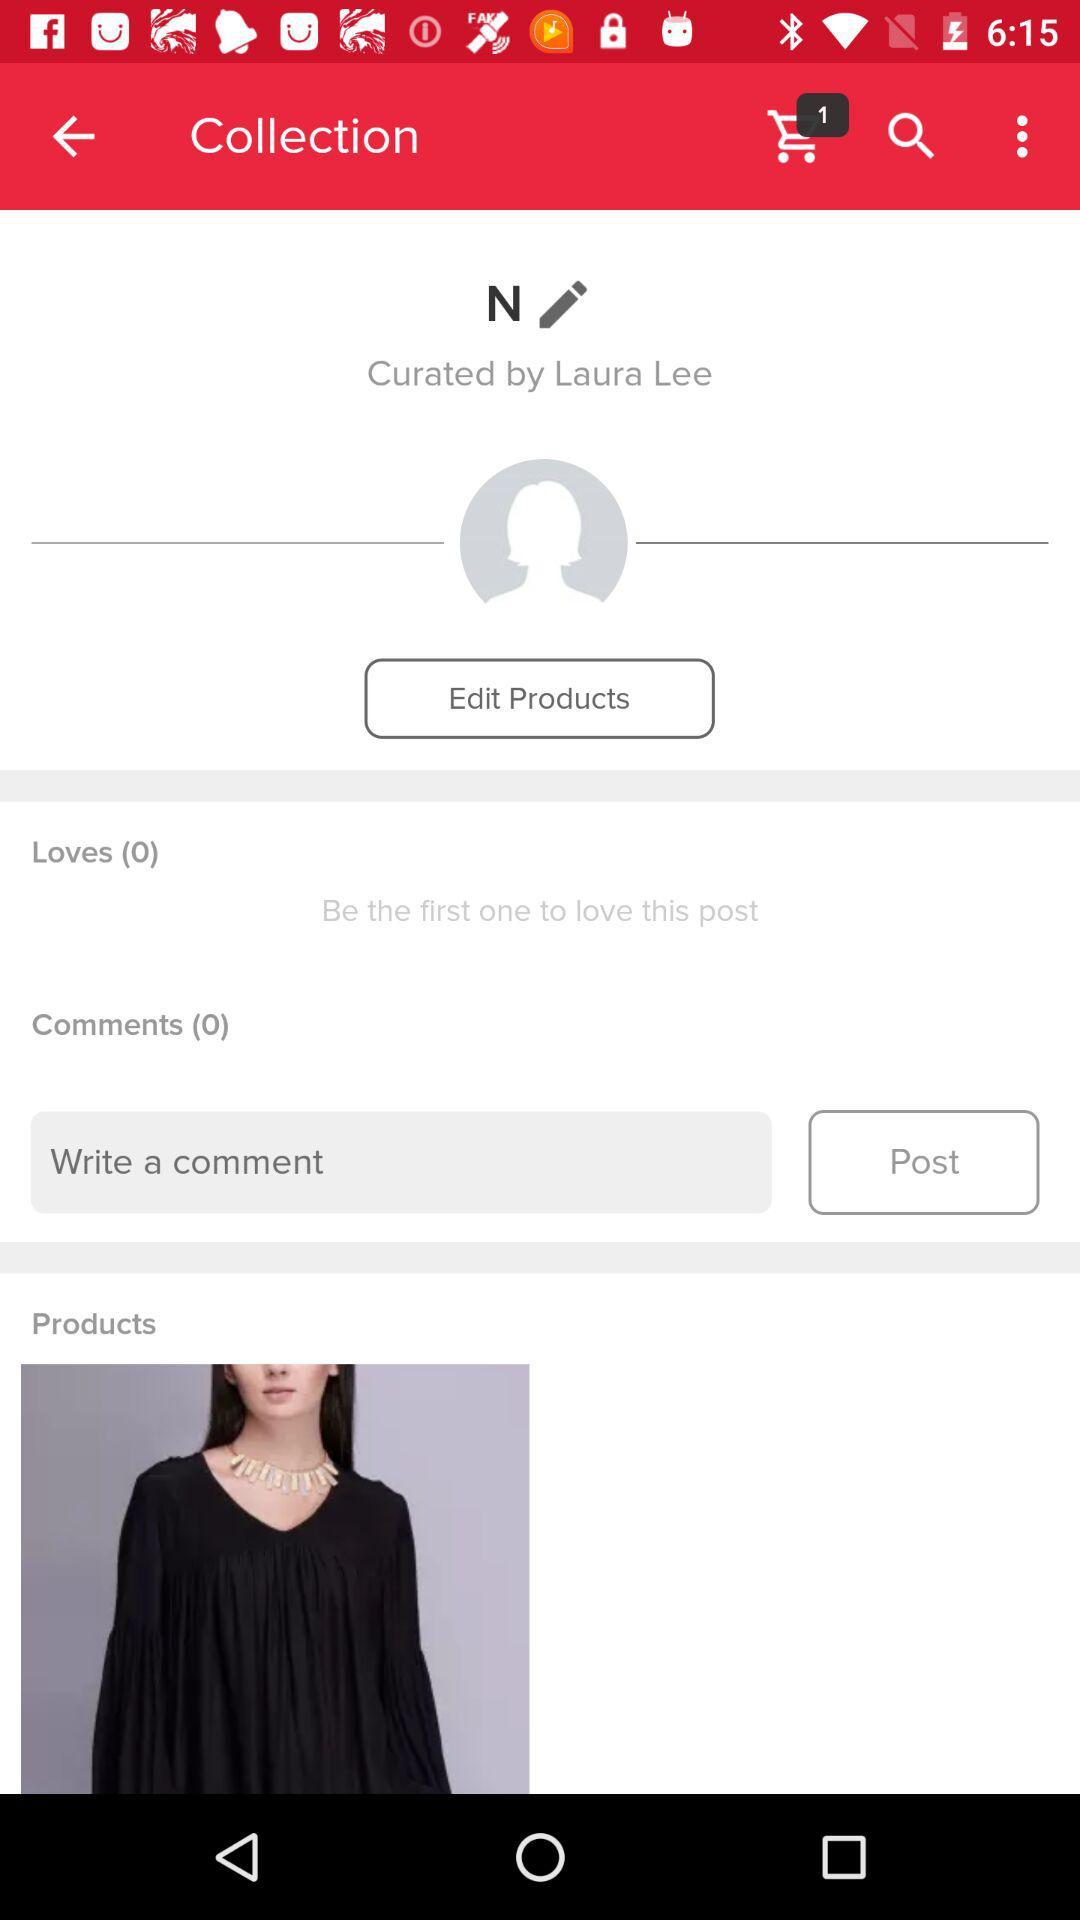How many more products than loves are there?
Answer the question using a single word or phrase. 1 